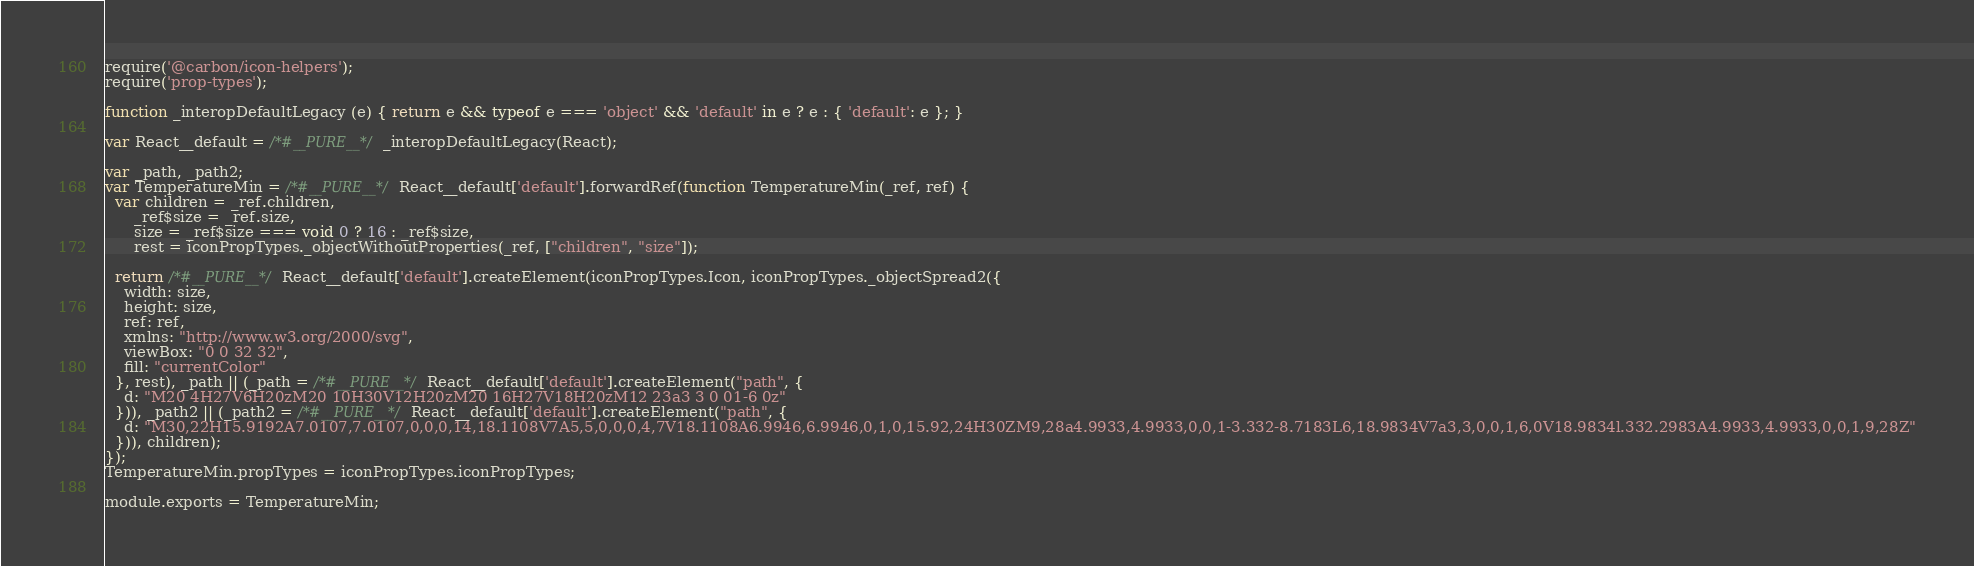Convert code to text. <code><loc_0><loc_0><loc_500><loc_500><_JavaScript_>require('@carbon/icon-helpers');
require('prop-types');

function _interopDefaultLegacy (e) { return e && typeof e === 'object' && 'default' in e ? e : { 'default': e }; }

var React__default = /*#__PURE__*/_interopDefaultLegacy(React);

var _path, _path2;
var TemperatureMin = /*#__PURE__*/React__default['default'].forwardRef(function TemperatureMin(_ref, ref) {
  var children = _ref.children,
      _ref$size = _ref.size,
      size = _ref$size === void 0 ? 16 : _ref$size,
      rest = iconPropTypes._objectWithoutProperties(_ref, ["children", "size"]);

  return /*#__PURE__*/React__default['default'].createElement(iconPropTypes.Icon, iconPropTypes._objectSpread2({
    width: size,
    height: size,
    ref: ref,
    xmlns: "http://www.w3.org/2000/svg",
    viewBox: "0 0 32 32",
    fill: "currentColor"
  }, rest), _path || (_path = /*#__PURE__*/React__default['default'].createElement("path", {
    d: "M20 4H27V6H20zM20 10H30V12H20zM20 16H27V18H20zM12 23a3 3 0 01-6 0z"
  })), _path2 || (_path2 = /*#__PURE__*/React__default['default'].createElement("path", {
    d: "M30,22H15.9192A7.0107,7.0107,0,0,0,14,18.1108V7A5,5,0,0,0,4,7V18.1108A6.9946,6.9946,0,1,0,15.92,24H30ZM9,28a4.9933,4.9933,0,0,1-3.332-8.7183L6,18.9834V7a3,3,0,0,1,6,0V18.9834l.332.2983A4.9933,4.9933,0,0,1,9,28Z"
  })), children);
});
TemperatureMin.propTypes = iconPropTypes.iconPropTypes;

module.exports = TemperatureMin;
</code> 